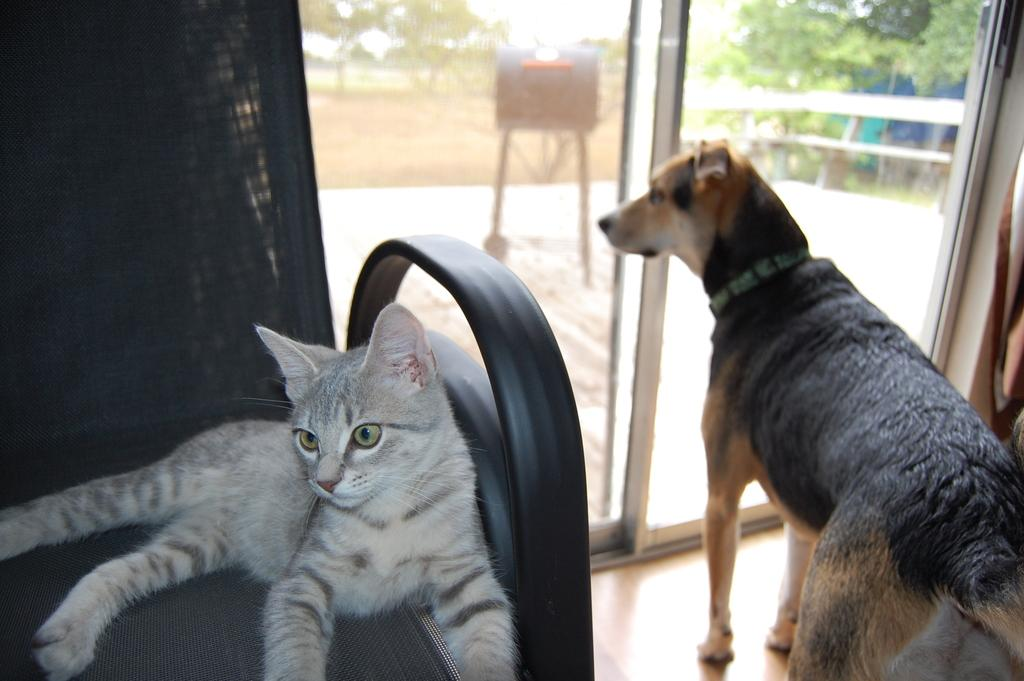What animal is lying in the chair in the image? There is a cat lying in a chair in the image. What animal is standing on the floor in the image? There is a dog standing on the floor in the image. What can be seen in the background of the image? The background of the image includes sky, the ground, trees, and a bench. What type of vein is visible on the cat's paw in the image? There are no veins visible on the cat's paw in the image. What knowledge is the dog gaining from the image? The dog is not gaining any knowledge from the image, as it is a static representation and does not convey information. 